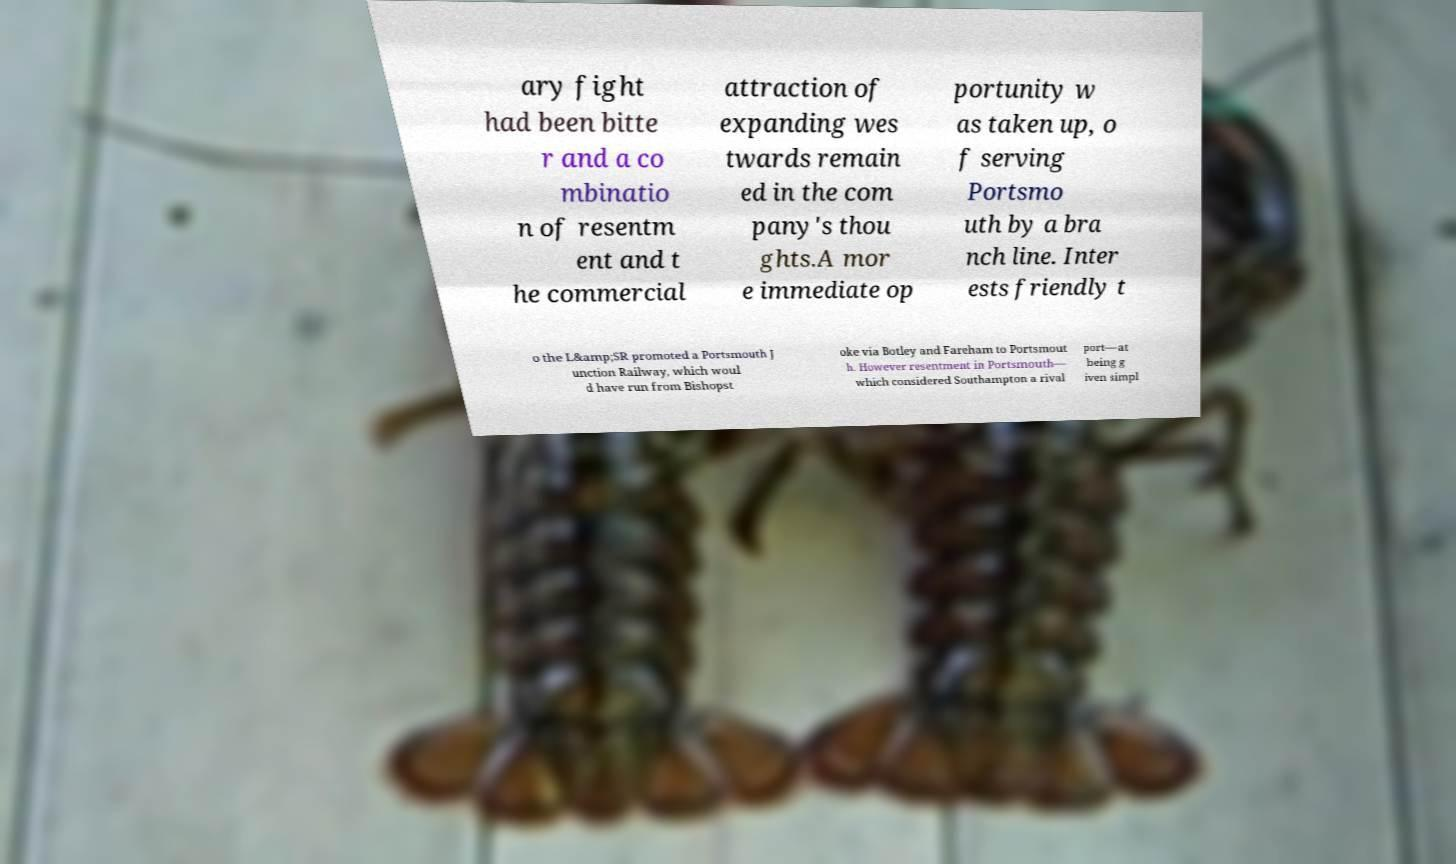Can you accurately transcribe the text from the provided image for me? ary fight had been bitte r and a co mbinatio n of resentm ent and t he commercial attraction of expanding wes twards remain ed in the com pany's thou ghts.A mor e immediate op portunity w as taken up, o f serving Portsmo uth by a bra nch line. Inter ests friendly t o the L&amp;SR promoted a Portsmouth J unction Railway, which woul d have run from Bishopst oke via Botley and Fareham to Portsmout h. However resentment in Portsmouth— which considered Southampton a rival port—at being g iven simpl 